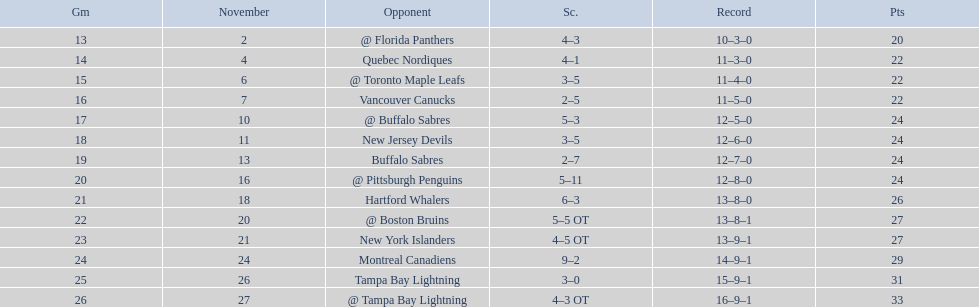Which teams scored 35 points or more in total? Hartford Whalers, @ Boston Bruins, New York Islanders, Montreal Canadiens, Tampa Bay Lightning, @ Tampa Bay Lightning. Of those teams, which team was the only one to score 3-0? Tampa Bay Lightning. 